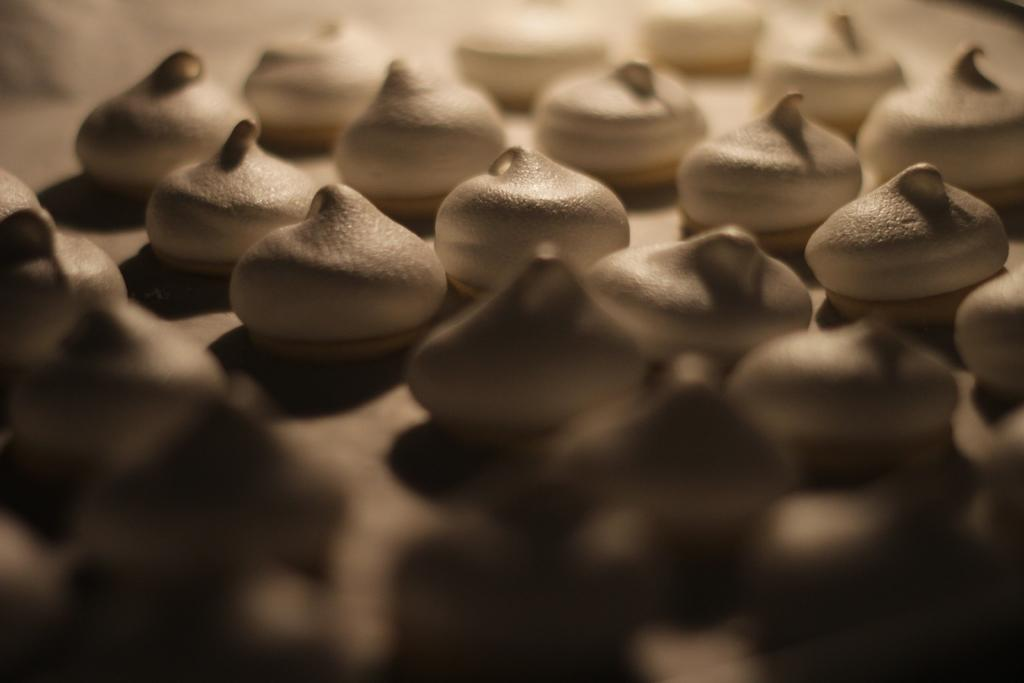What can be seen in the image? There is an object in the image. What is inside the object? The object contains food items. What type of art can be seen in the mist in the image? There is no mist or art present in the image; it only contains an object with food items. 